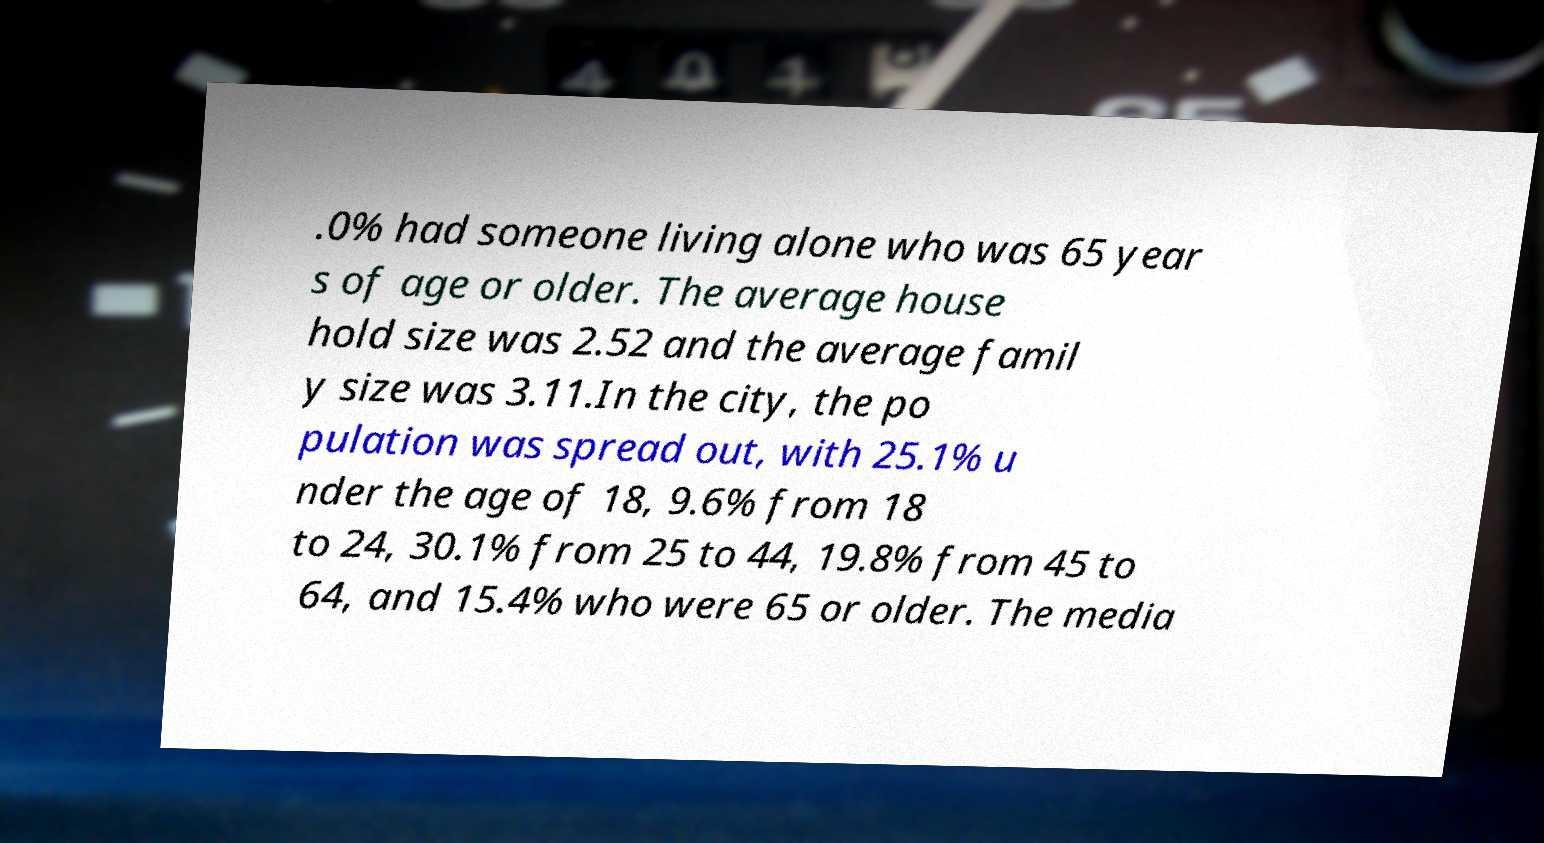Please identify and transcribe the text found in this image. .0% had someone living alone who was 65 year s of age or older. The average house hold size was 2.52 and the average famil y size was 3.11.In the city, the po pulation was spread out, with 25.1% u nder the age of 18, 9.6% from 18 to 24, 30.1% from 25 to 44, 19.8% from 45 to 64, and 15.4% who were 65 or older. The media 